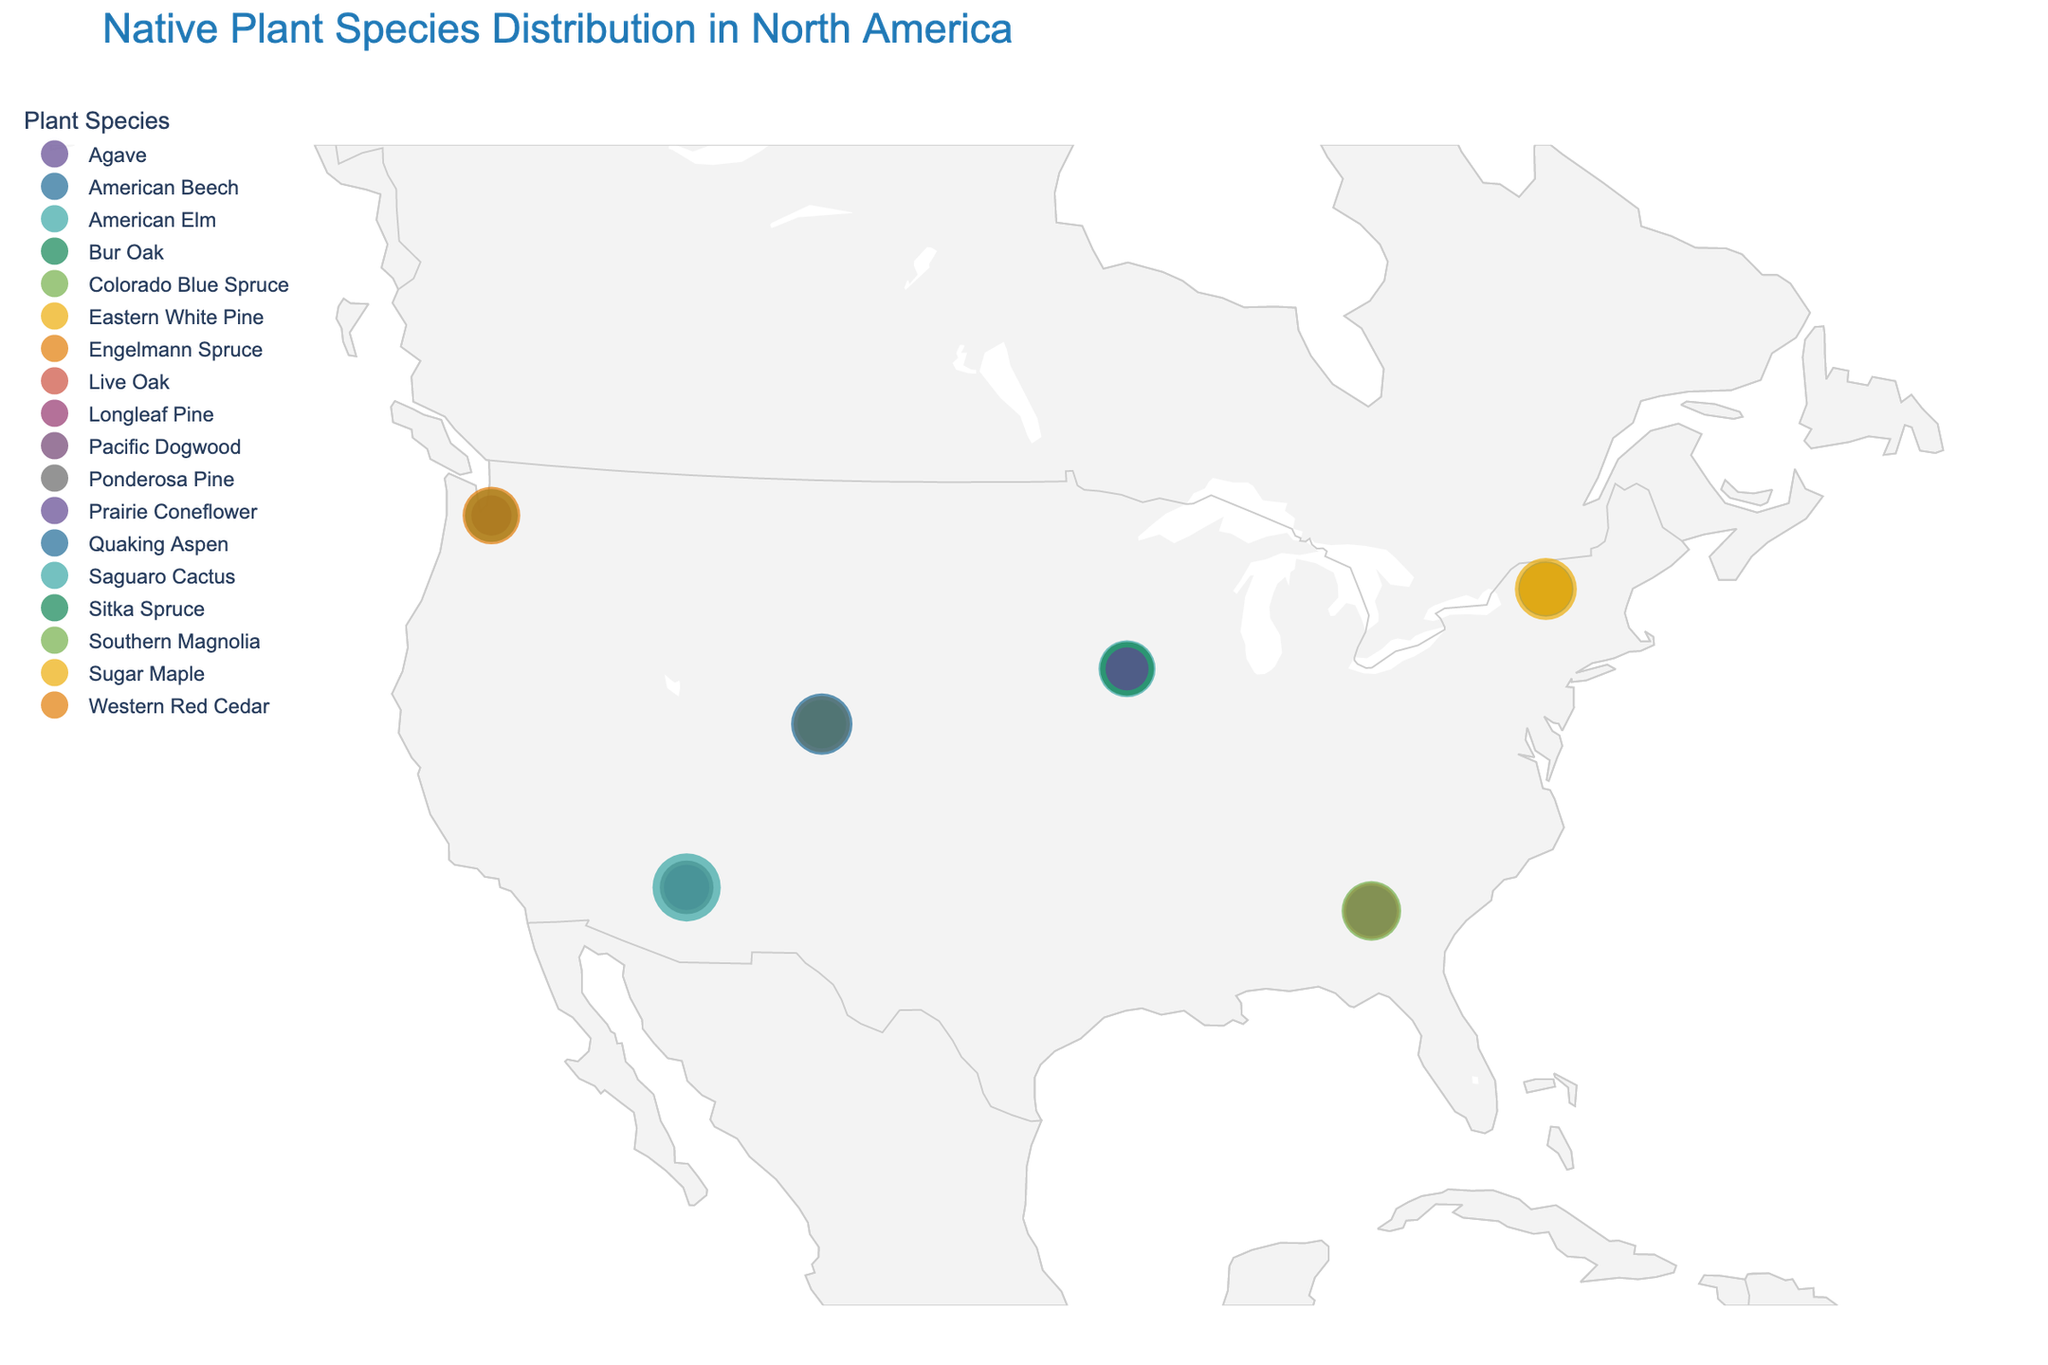Which region has the highest prevalence of a single plant species? Look for the data point with the largest marker size in the plot. The Southwest region has the Saguaro Cactus with a prevalence of 63%.
Answer: Southwest What is the total prevalence of plant species in the Pacific Northwest region? Add the prevalence percentages of Western Red Cedar (45%), Sitka Spruce (38%), and Pacific Dogwood (22%). 45 + 38 + 22 = 105.
Answer: 105% How many plant species are displayed in the Southeast region? Count the distinct markers for Southern Magnolia, Live Oak, and Longleaf Pine in the Southeast region. There are three.
Answer: 3 Which plant species in the Rocky Mountains region has the lowest prevalence? Compare the prevalence percentages of Quaking Aspen (51%), Engelmann Spruce (43%), and Colorado Blue Spruce (32%). Colorado Blue Spruce has the lowest prevalence.
Answer: Colorado Blue Spruce Which two regions have the same number of distinct plant species displayed? Compare the number of unique plant species for each region. Pacific Northwest and Southeast each have three distinct species.
Answer: Pacific Northwest and Southeast How does the prevalence of American Beech in the Northeast compare to American Elm in the Midwest? American Beech in the Northeast has a prevalence of 41%, and American Elm in the Midwest has 44%. Therefore, American Elm has a higher prevalence.
Answer: American Elm is higher What is the average prevalence of plant species in the Northeast region? Sum the prevalence percentages of Sugar Maple (52%), American Beech (41%), and Eastern White Pine (37%) and then divide by 3. (52 + 41 + 37) / 3 = 43.33
Answer: 43.33% Which plant species appears in both Pacific Northwest and Southwest regions? Scan the plant species in both regions to find a common one. Ponderosa Pine is only in the Southwest, none are common.
Answer: None What region has the highest combined prevalence of coniferous trees? Calculate the combined prevalence of coniferous trees for all regions, comparing the sums:
- Pacific Northwest: Western Red Cedar (45%) + Sitka Spruce (38%) = 83%
- Northeast: Eastern White Pine (37%) = 37%
- Southwest: Ponderosa Pine (39%) = 39%
- Southeast: Longleaf Pine (35%) = 35%
- Midwest: None
- Rocky Mountains: Engelmann Spruce (43%) + Colorado Blue Spruce (32%) = 75% 
Pacific Northwest has the highest combined prevalence of coniferous trees.
Answer: Pacific Northwest Which region has the lowest total prevalence of plant species? Add up the total prevalence percentages for all regions and compare:
- Pacific Northwest: 105%
- Northeast: 130%
- Southwest: 130%
- Southeast: 125%
- Midwest: 108%
- Rocky Mountains: 126%
Midwest has the lowest total prevalence.
Answer: Midwest 